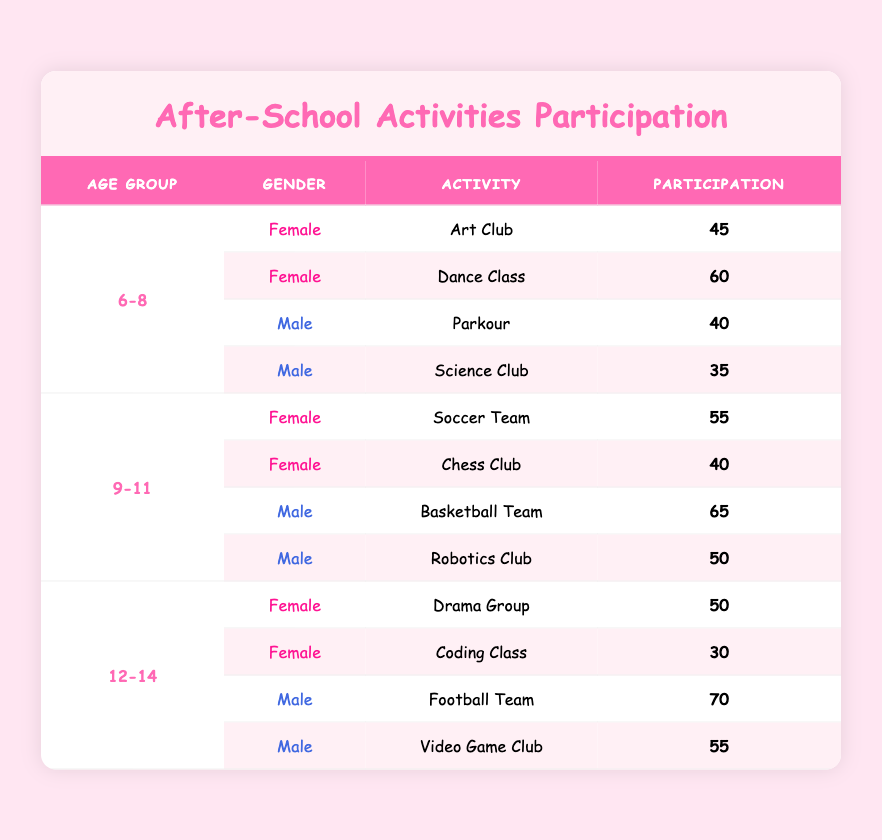What is the participation count for females in Dance Class in the age group 6-8? The table shows that for females aged 6-8, the participation in Dance Class is listed under the respective row, which states a participation count of 60.
Answer: 60 What is the participation count for males in the Football Team for the age group 12-14? Looking at the table, the row for males aged 12-14 states their participation in the Football Team is 70.
Answer: 70 Which activity had the highest participation among males aged 9-11? By scanning through the rows for males aged 9-11, we find that the Basketball Team has a participation of 65, which is the highest among the activities listed for this age group.
Answer: Basketball Team What is the total participation count of females in the age group 12-14? For females aged 12-14, the participation counts are 50 for Drama Group and 30 for Coding Class. Therefore, the total is 50 + 30 = 80.
Answer: 80 Is there more participation in the Soccer Team or the Art Club? Checking the participation counts, the Soccer Team for females aged 9-11 has 55, while the Art Club for females aged 6-8 has 45. Since 55 is greater than 45, there is more participation in the Soccer Team.
Answer: Yes What is the average participation of females in all activities across the three age groups? First, we identify the female participation: 45, 60, 55, 40, 50, and 30. Next, we sum these values (45 + 60 + 55 + 40 + 50 + 30 = 280). Since there are 6 data points, the average is 280 / 6 = 46.67.
Answer: 46.67 Which activity has the lowest participation for males in the age group 6-8? Comparing the participation counts for males aged 6-8, Parkour has 40 and Science Club has 35. Therefore, the Science Club has the lowest participation.
Answer: Science Club How many total participants are in the Coding Class and Video Game Club combined? The Coding Class for females aged 12-14 has 30 participants, and the Video Game Club for males aged 12-14 has 55 participants. Adding these counts together gives 30 + 55 = 85 total participants.
Answer: 85 Did any males in the age group 6-8 participate in any activities more than 40? In the table, the participation for males aged 6-8 in Parkour is 40, and in Science Club is 35. Since neither exceeds 40, the answer is no.
Answer: No 